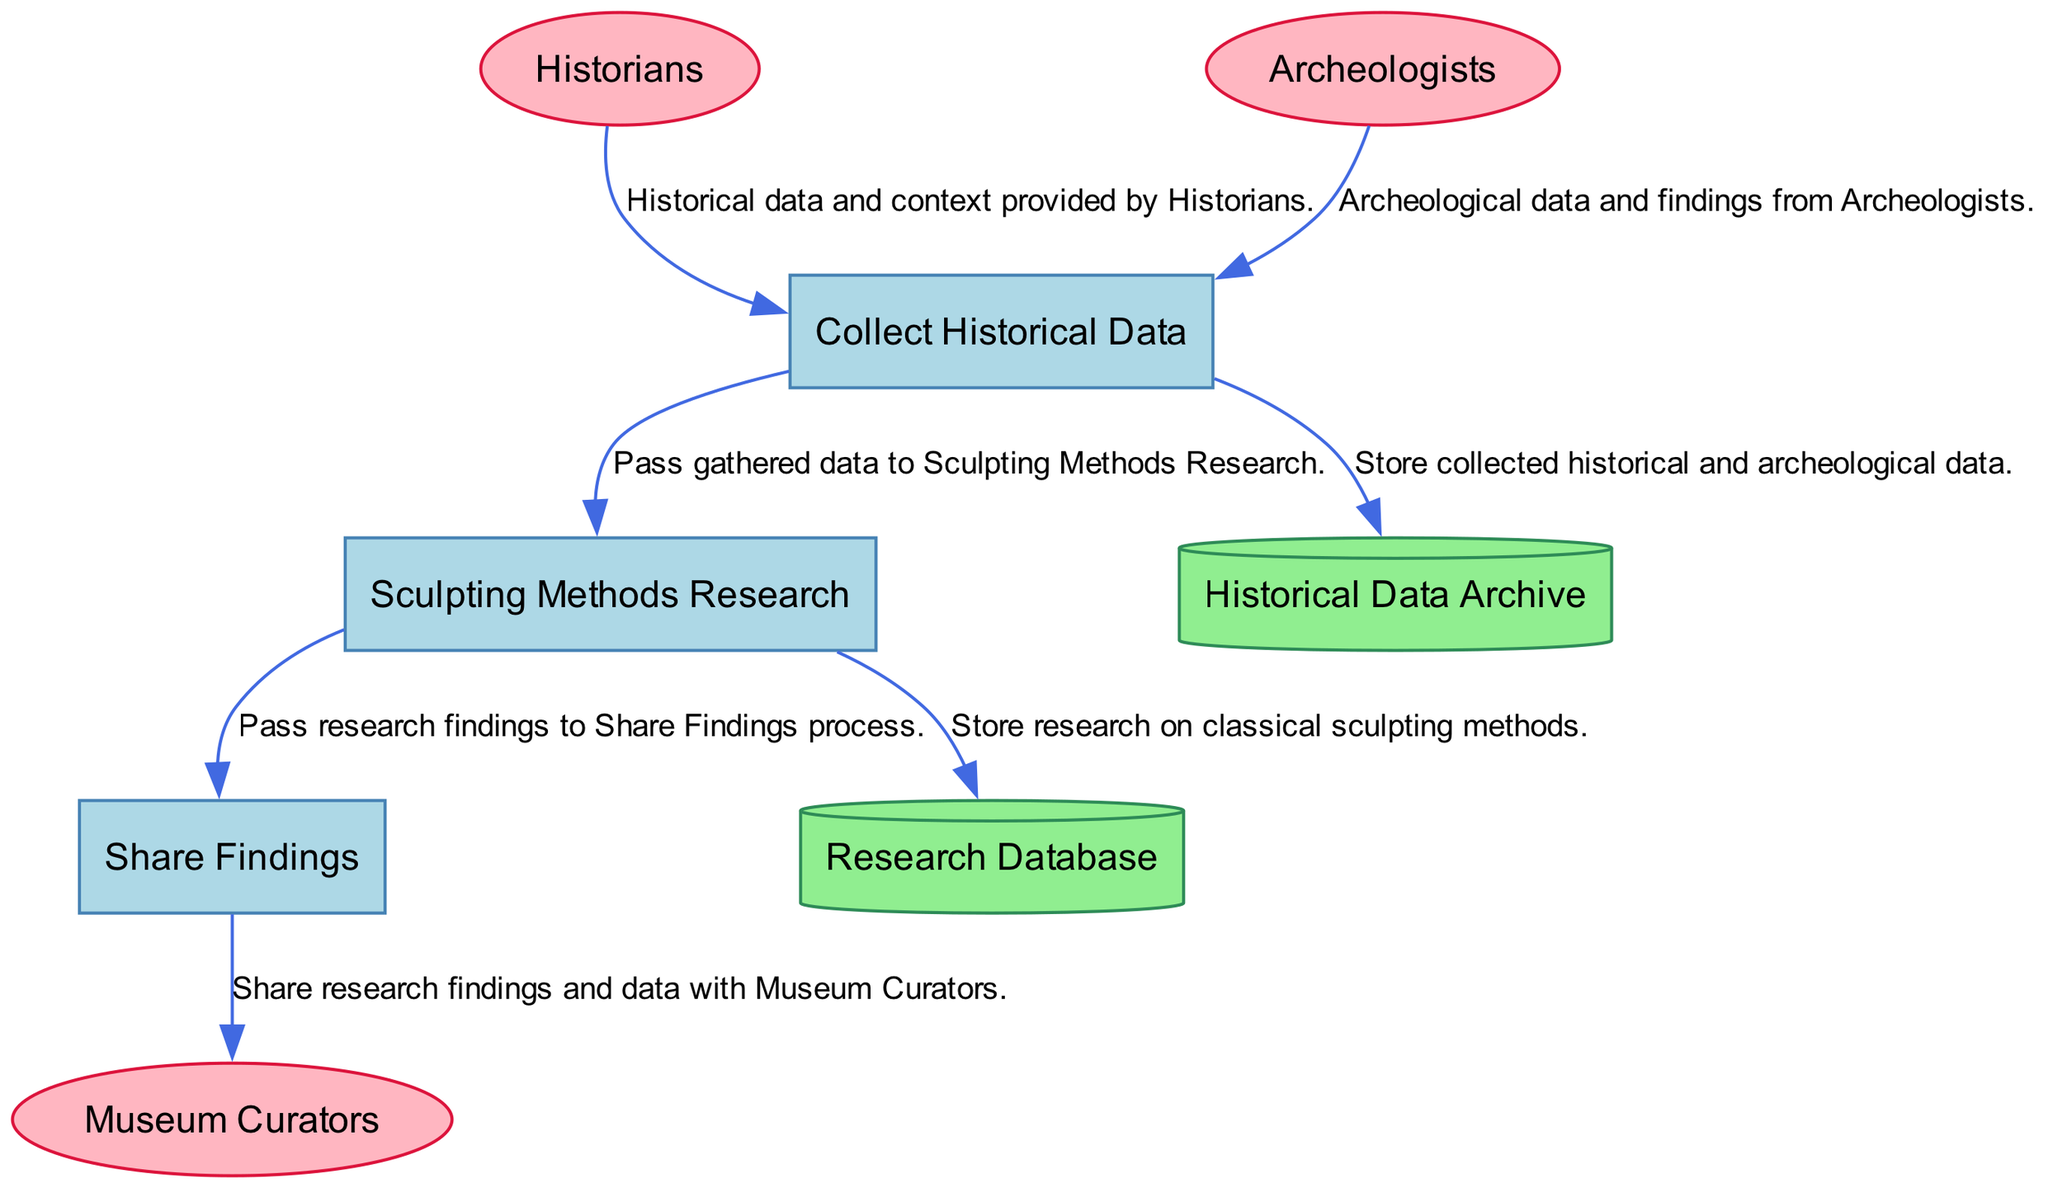What is the name of the process that gathers historical information? The process that gathers historical information on ancient Greek sculptures is labeled as "Collect Historical Data."
Answer: Collect Historical Data How many external entities are involved in this diagram? There are three external entities: Historians, Archeologists, and Museum Curators. Count them to find the total number.
Answer: 3 What does the flow from Historians to "Collect Historical Data" represent? The flow from Historians to "Collect Historical Data" represents the historical data and context provided by Historians for their collaboration.
Answer: Historical data and context Which data store is used to archive research on sculpting methods? The data store used to archive research on sculpting methods is named "Research Database."
Answer: Research Database What is the last step in the process flow before sharing findings? The last step in the process flow before sharing findings is the "Sculpting Methods Research" process, which passes research findings to the "Share Findings" process.
Answer: Sculpting Methods Research What do Archeologists provide to the "Collect Historical Data" process? Archeologists provide archeological data and findings which are necessary for the historical context of the sculptures.
Answer: Archeological data and findings What type of node is the "Research Database"? The "Research Database" is a data store, specifically represented as a cylinder in the diagram to indicate its function.
Answer: Data store Which entities are receiving the findings from the "Share Findings" process? The entity receiving the findings from the "Share Findings" process is "Museum Curators," indicating the collaboration on data and research findings.
Answer: Museum Curators Which data flow indicates the storage of historical data? The flow labeled as F3 indicates that the collected historical and archeological data is stored in the Historical Data Archive.
Answer: Historical Data Archive 